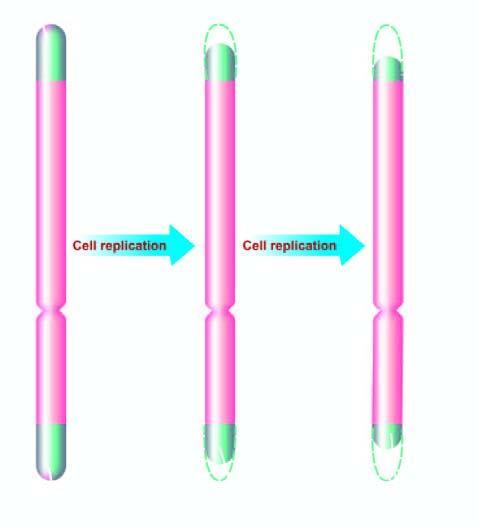re nuclei progressively shortened in aging?
Answer the question using a single word or phrase. No 